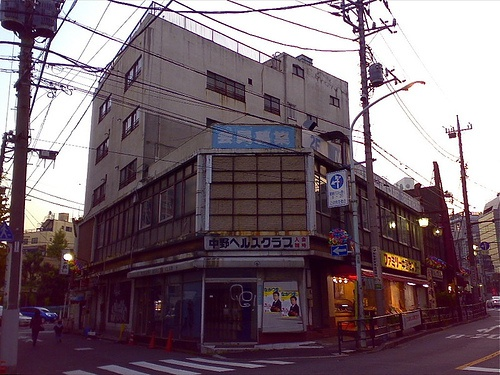Describe the objects in this image and their specific colors. I can see traffic light in lightgray, black, and purple tones, people in lightgray, black, purple, and navy tones, car in lightgray, navy, and purple tones, people in lightgray, black, maroon, brown, and purple tones, and car in lightgray, purple, black, and darkgray tones in this image. 